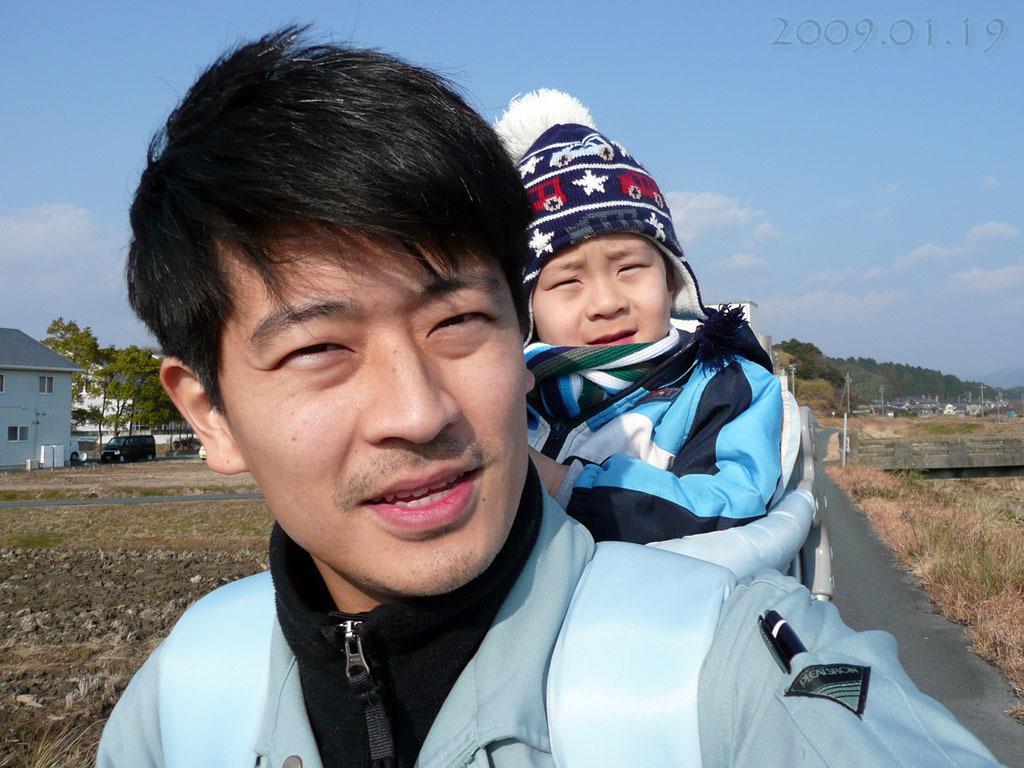Can you describe this image briefly? In this image we can see a man and a boy. The man is wearing light blue color jacket and carrying the boy on his back. The boy is wearing blue and black color jacket. We can see grassy land, house, car and trees in the background. We can see the blue color sky with some clouds. 